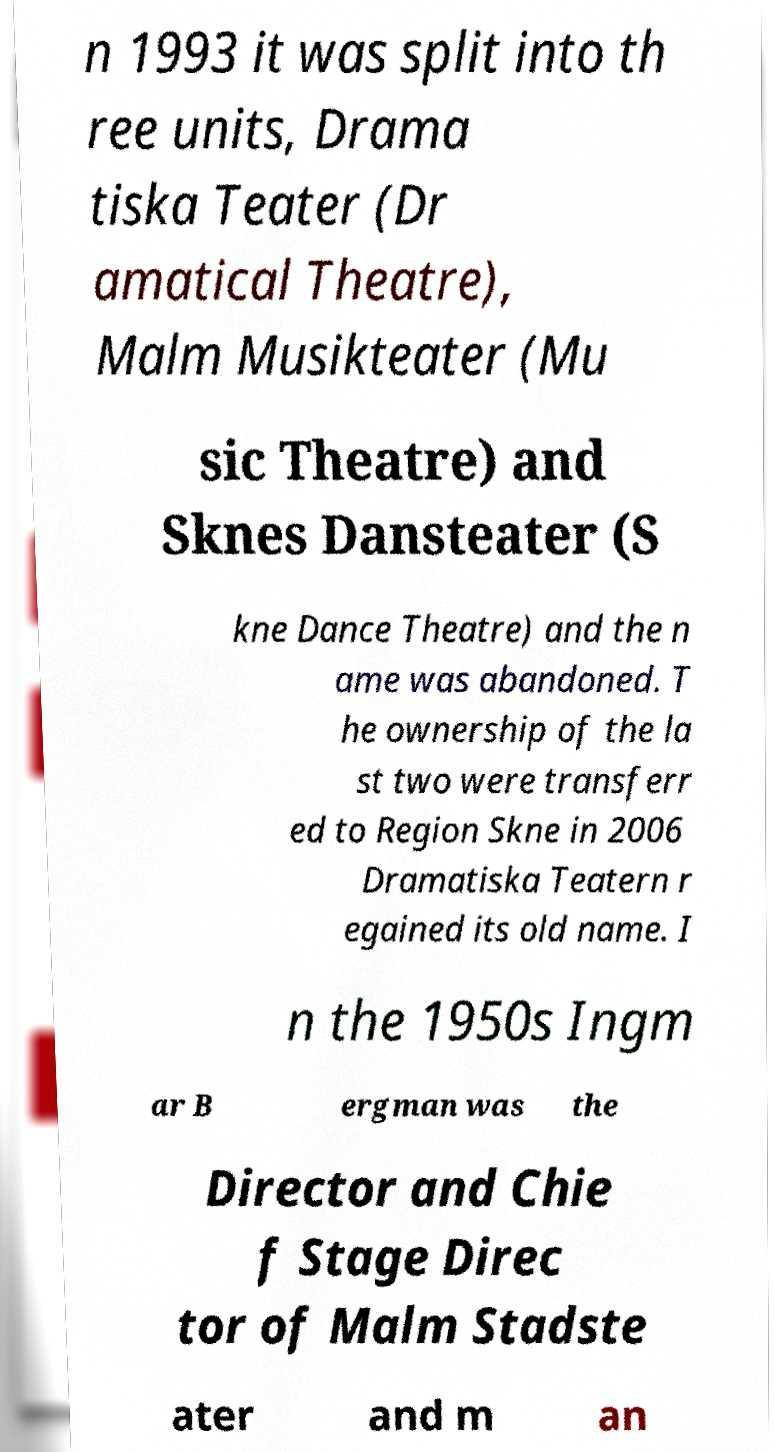I need the written content from this picture converted into text. Can you do that? n 1993 it was split into th ree units, Drama tiska Teater (Dr amatical Theatre), Malm Musikteater (Mu sic Theatre) and Sknes Dansteater (S kne Dance Theatre) and the n ame was abandoned. T he ownership of the la st two were transferr ed to Region Skne in 2006 Dramatiska Teatern r egained its old name. I n the 1950s Ingm ar B ergman was the Director and Chie f Stage Direc tor of Malm Stadste ater and m an 